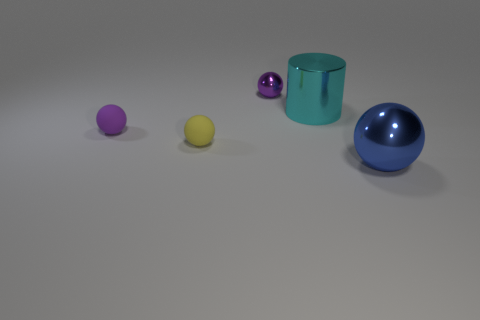Subtract all large spheres. How many spheres are left? 3 Add 5 small purple rubber cylinders. How many objects exist? 10 Subtract all cylinders. How many objects are left? 4 Add 4 small yellow matte balls. How many small yellow matte balls exist? 5 Subtract all blue spheres. How many spheres are left? 3 Subtract 0 purple cubes. How many objects are left? 5 Subtract 1 spheres. How many spheres are left? 3 Subtract all cyan balls. Subtract all purple blocks. How many balls are left? 4 Subtract all blue spheres. How many brown cylinders are left? 0 Subtract all large blue things. Subtract all blue metal spheres. How many objects are left? 3 